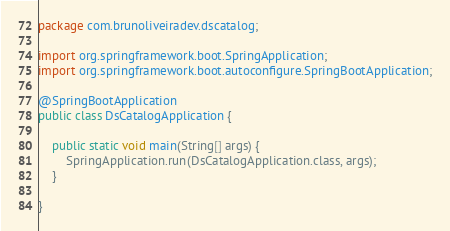Convert code to text. <code><loc_0><loc_0><loc_500><loc_500><_Java_>package com.brunoliveiradev.dscatalog;

import org.springframework.boot.SpringApplication;
import org.springframework.boot.autoconfigure.SpringBootApplication;

@SpringBootApplication
public class DsCatalogApplication {

	public static void main(String[] args) {
		SpringApplication.run(DsCatalogApplication.class, args);
	}

}
</code> 